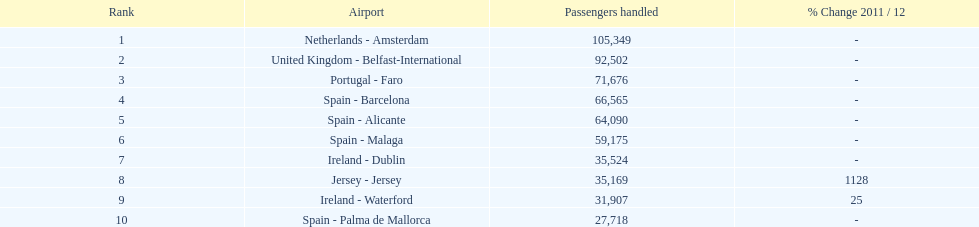At a spanish airport, how many passengers were processed? 217,548. 